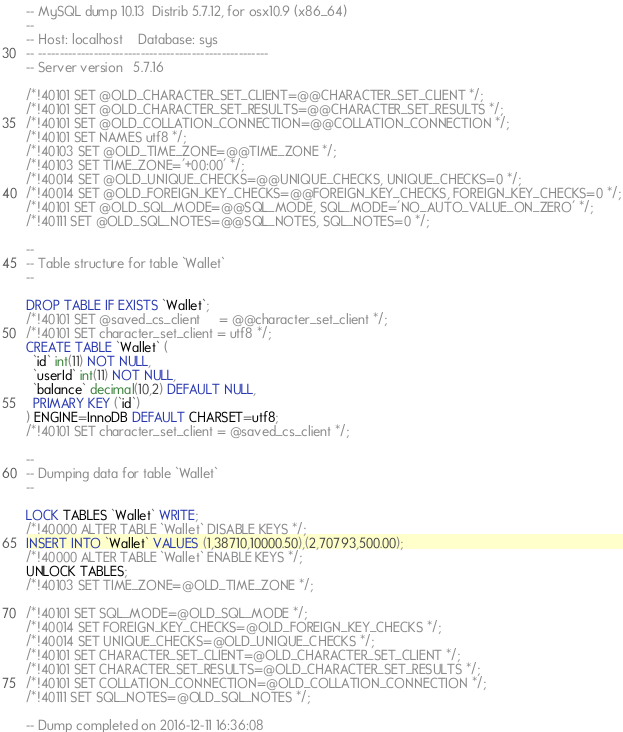Convert code to text. <code><loc_0><loc_0><loc_500><loc_500><_SQL_>-- MySQL dump 10.13  Distrib 5.7.12, for osx10.9 (x86_64)
--
-- Host: localhost    Database: sys
-- ------------------------------------------------------
-- Server version	5.7.16

/*!40101 SET @OLD_CHARACTER_SET_CLIENT=@@CHARACTER_SET_CLIENT */;
/*!40101 SET @OLD_CHARACTER_SET_RESULTS=@@CHARACTER_SET_RESULTS */;
/*!40101 SET @OLD_COLLATION_CONNECTION=@@COLLATION_CONNECTION */;
/*!40101 SET NAMES utf8 */;
/*!40103 SET @OLD_TIME_ZONE=@@TIME_ZONE */;
/*!40103 SET TIME_ZONE='+00:00' */;
/*!40014 SET @OLD_UNIQUE_CHECKS=@@UNIQUE_CHECKS, UNIQUE_CHECKS=0 */;
/*!40014 SET @OLD_FOREIGN_KEY_CHECKS=@@FOREIGN_KEY_CHECKS, FOREIGN_KEY_CHECKS=0 */;
/*!40101 SET @OLD_SQL_MODE=@@SQL_MODE, SQL_MODE='NO_AUTO_VALUE_ON_ZERO' */;
/*!40111 SET @OLD_SQL_NOTES=@@SQL_NOTES, SQL_NOTES=0 */;

--
-- Table structure for table `Wallet`
--

DROP TABLE IF EXISTS `Wallet`;
/*!40101 SET @saved_cs_client     = @@character_set_client */;
/*!40101 SET character_set_client = utf8 */;
CREATE TABLE `Wallet` (
  `id` int(11) NOT NULL,
  `userId` int(11) NOT NULL,
  `balance` decimal(10,2) DEFAULT NULL,
  PRIMARY KEY (`id`)
) ENGINE=InnoDB DEFAULT CHARSET=utf8;
/*!40101 SET character_set_client = @saved_cs_client */;

--
-- Dumping data for table `Wallet`
--

LOCK TABLES `Wallet` WRITE;
/*!40000 ALTER TABLE `Wallet` DISABLE KEYS */;
INSERT INTO `Wallet` VALUES (1,38710,10000.50),(2,70793,500.00);
/*!40000 ALTER TABLE `Wallet` ENABLE KEYS */;
UNLOCK TABLES;
/*!40103 SET TIME_ZONE=@OLD_TIME_ZONE */;

/*!40101 SET SQL_MODE=@OLD_SQL_MODE */;
/*!40014 SET FOREIGN_KEY_CHECKS=@OLD_FOREIGN_KEY_CHECKS */;
/*!40014 SET UNIQUE_CHECKS=@OLD_UNIQUE_CHECKS */;
/*!40101 SET CHARACTER_SET_CLIENT=@OLD_CHARACTER_SET_CLIENT */;
/*!40101 SET CHARACTER_SET_RESULTS=@OLD_CHARACTER_SET_RESULTS */;
/*!40101 SET COLLATION_CONNECTION=@OLD_COLLATION_CONNECTION */;
/*!40111 SET SQL_NOTES=@OLD_SQL_NOTES */;

-- Dump completed on 2016-12-11 16:36:08
</code> 